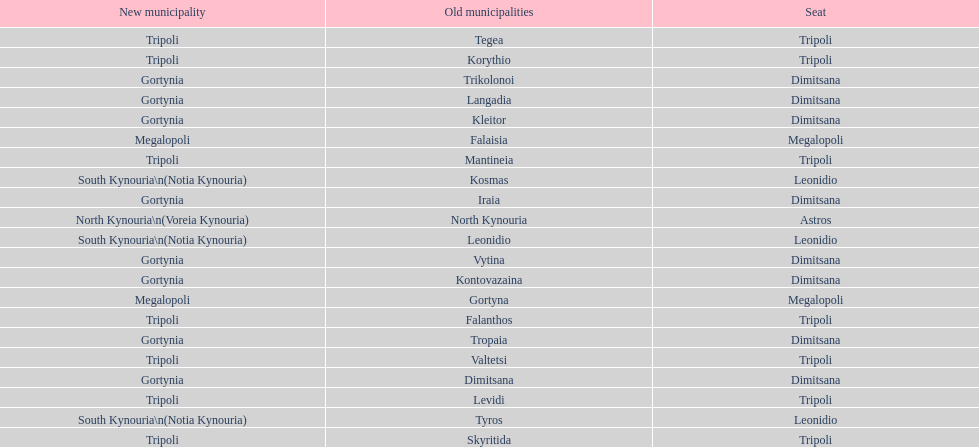When arcadia was reformed in 2011, how many municipalities were created? 5. 